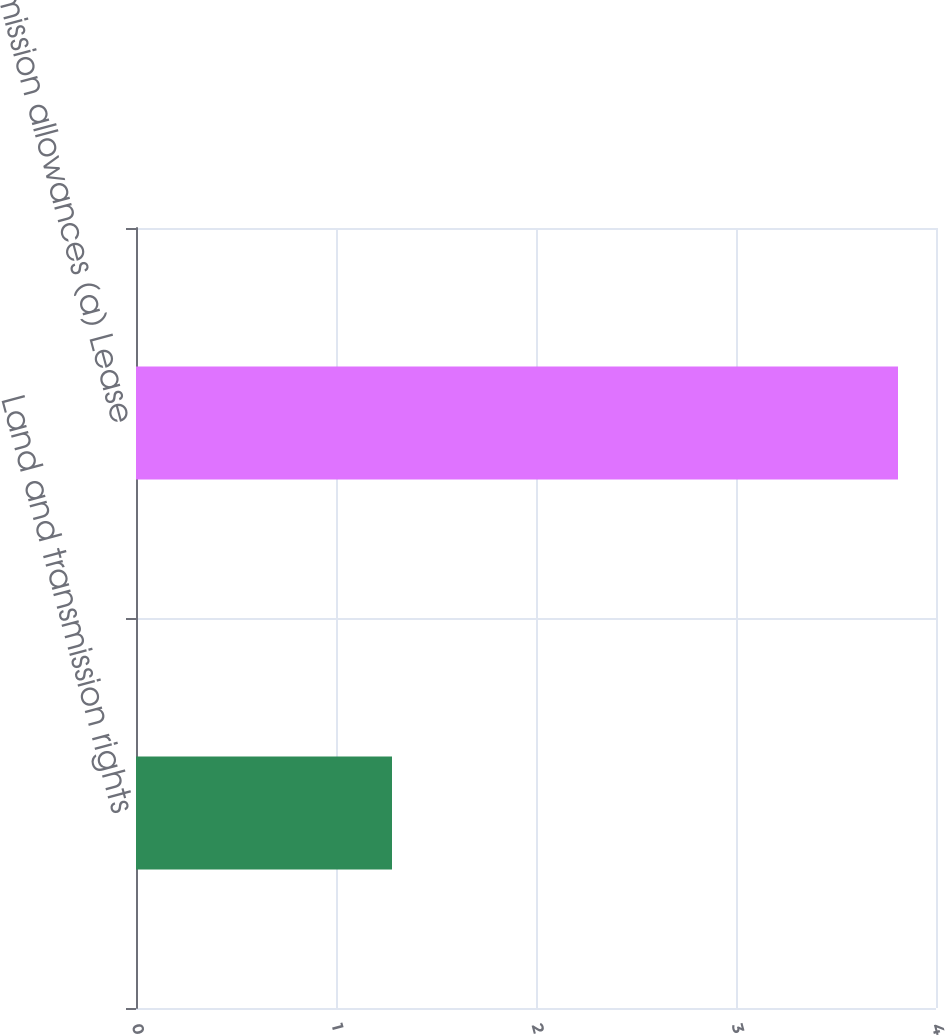Convert chart. <chart><loc_0><loc_0><loc_500><loc_500><bar_chart><fcel>Land and transmission rights<fcel>Emission allowances (a) Lease<nl><fcel>1.28<fcel>3.81<nl></chart> 